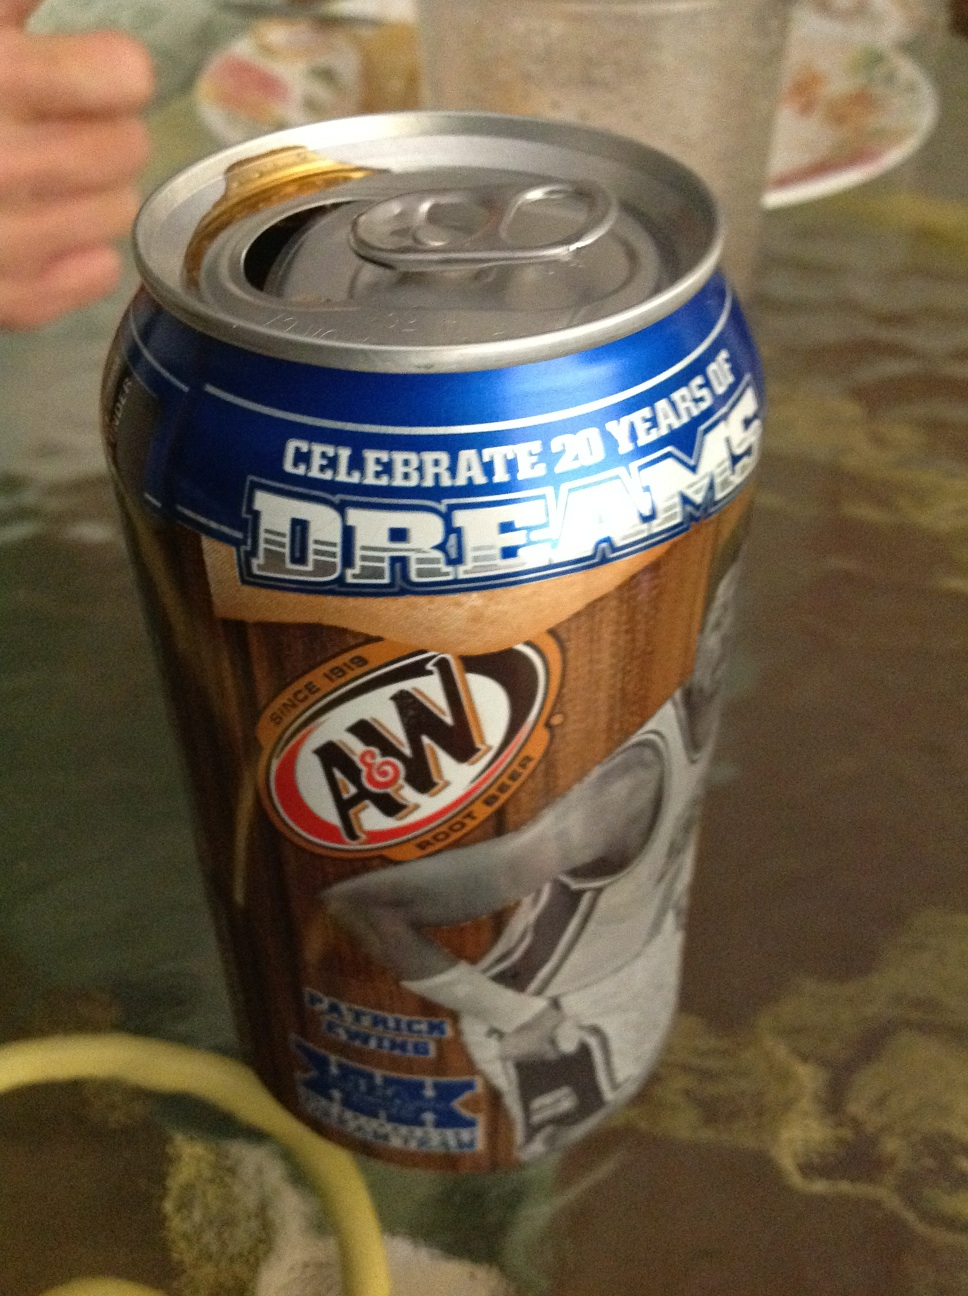Who is the player featured on the can? The can features a picture of Patrick Ewing, a famous basketball player. This suggests that A&W may have created this special edition to honor his contributions to the sport. 